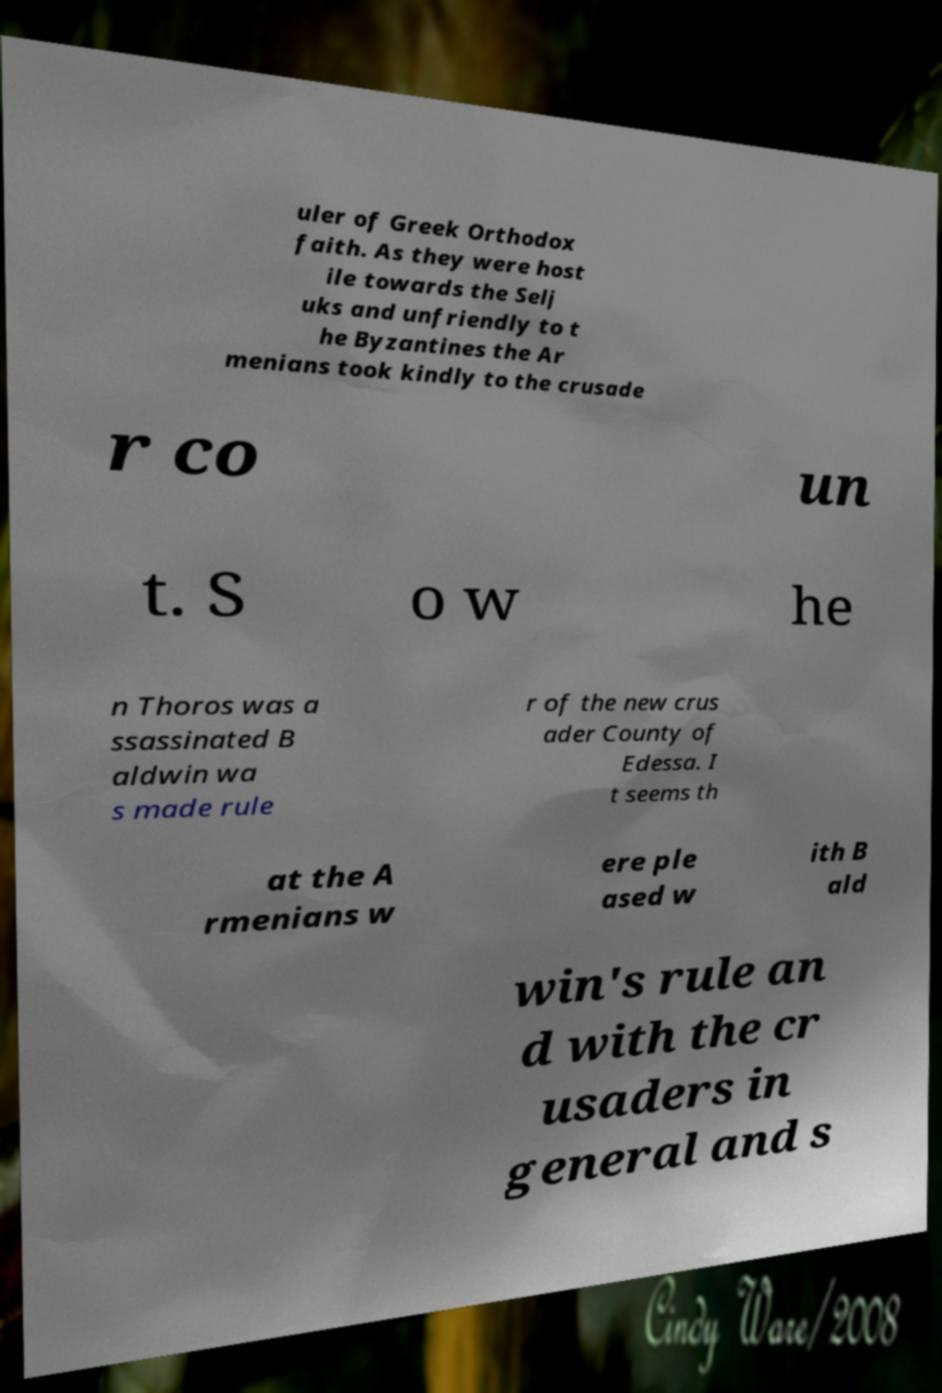Could you extract and type out the text from this image? uler of Greek Orthodox faith. As they were host ile towards the Selj uks and unfriendly to t he Byzantines the Ar menians took kindly to the crusade r co un t. S o w he n Thoros was a ssassinated B aldwin wa s made rule r of the new crus ader County of Edessa. I t seems th at the A rmenians w ere ple ased w ith B ald win's rule an d with the cr usaders in general and s 